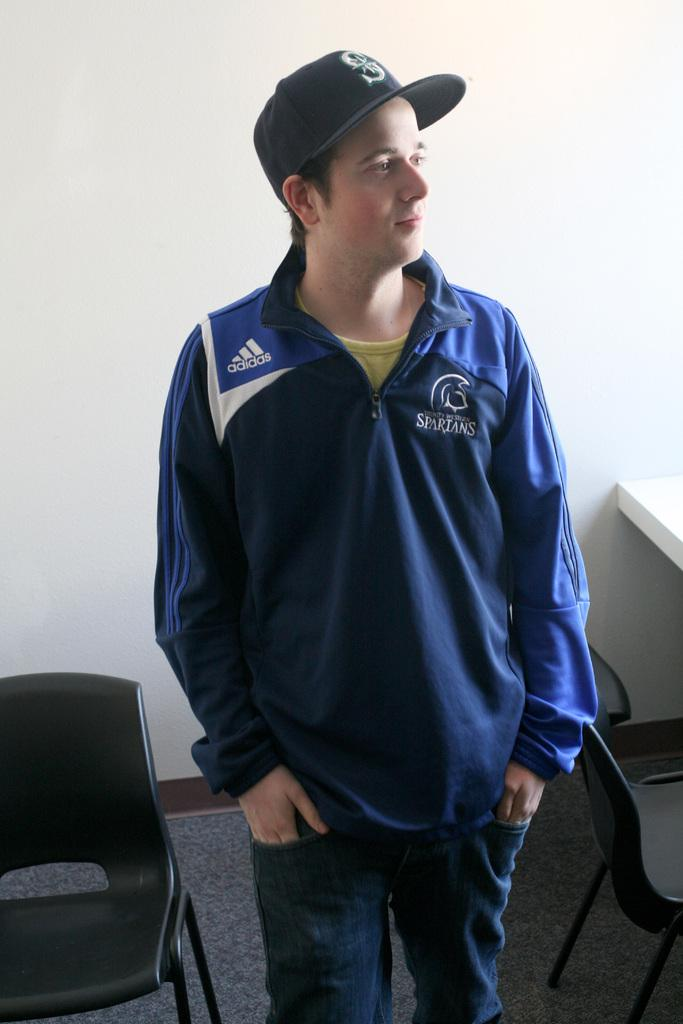<image>
Offer a succinct explanation of the picture presented. A young male wears a baseball cap and a blue Adidas pullover. 